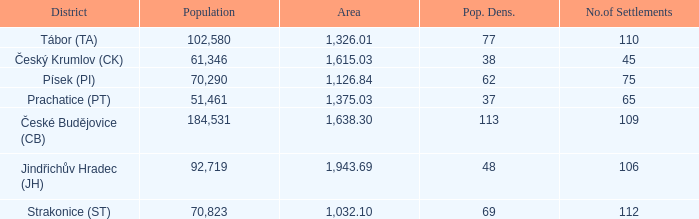What is the lowest population density of Strakonice (st) with more than 112 settlements? None. 